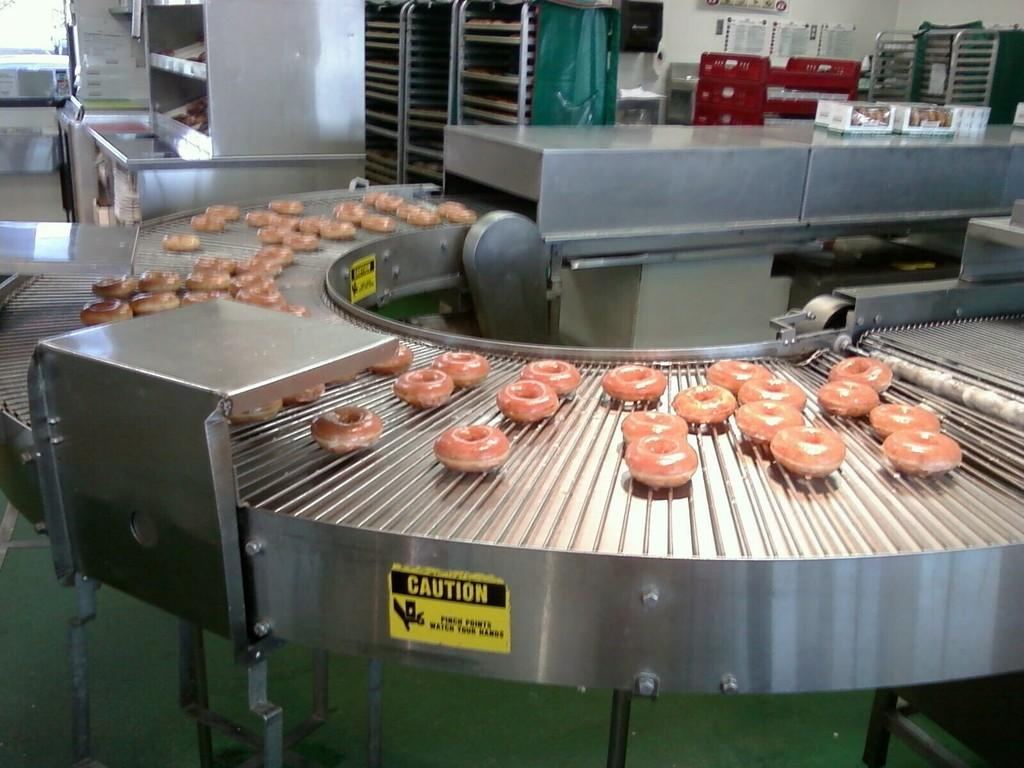Provide a one-sentence caption for the provided image. a bunch of doughnuts on a conveyer belt with a yellow caution sticker. 